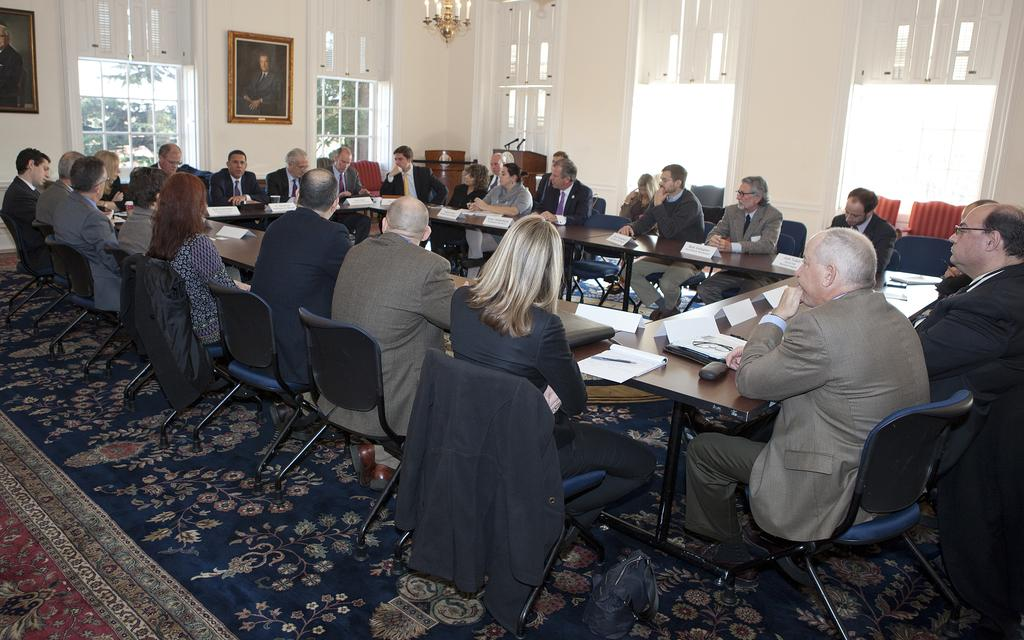How many people are in the image? There is a group of people in the image. What are the people doing in the image? The people are sitting on chairs. What can be seen on the table in the background? There are papers and a board on the table in the background. What is on the wall in the background? There is a frame on a wall in the background. What is visible outside the window in the background? There is a tree visible in the background. What type of experience can be gained from the quarter in the image? There is no quarter present in the image, so it is not possible to gain any experience from it. 